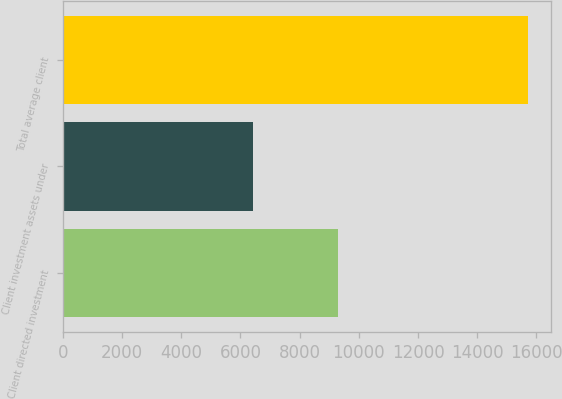Convert chart. <chart><loc_0><loc_0><loc_500><loc_500><bar_chart><fcel>Client directed investment<fcel>Client investment assets under<fcel>Total average client<nl><fcel>9279<fcel>6432<fcel>15711<nl></chart> 